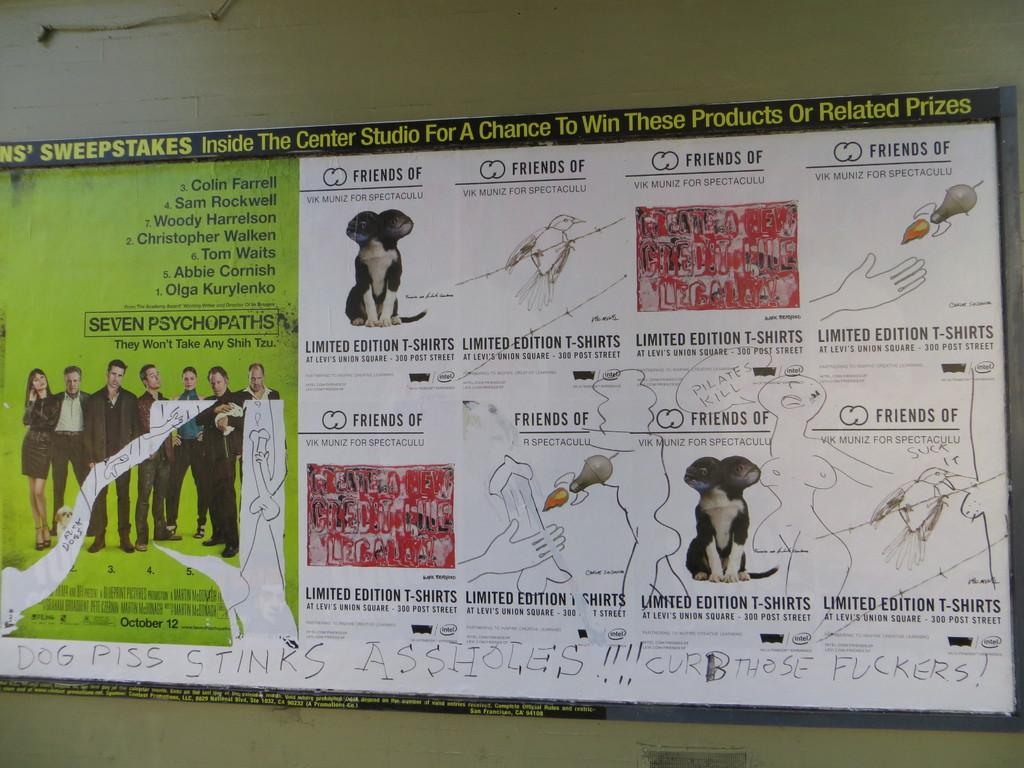<image>
Offer a succinct explanation of the picture presented. A poster describes a sweepstakes and features the names of actors like Collin Farrell, Sam Rockwell, among many others. 